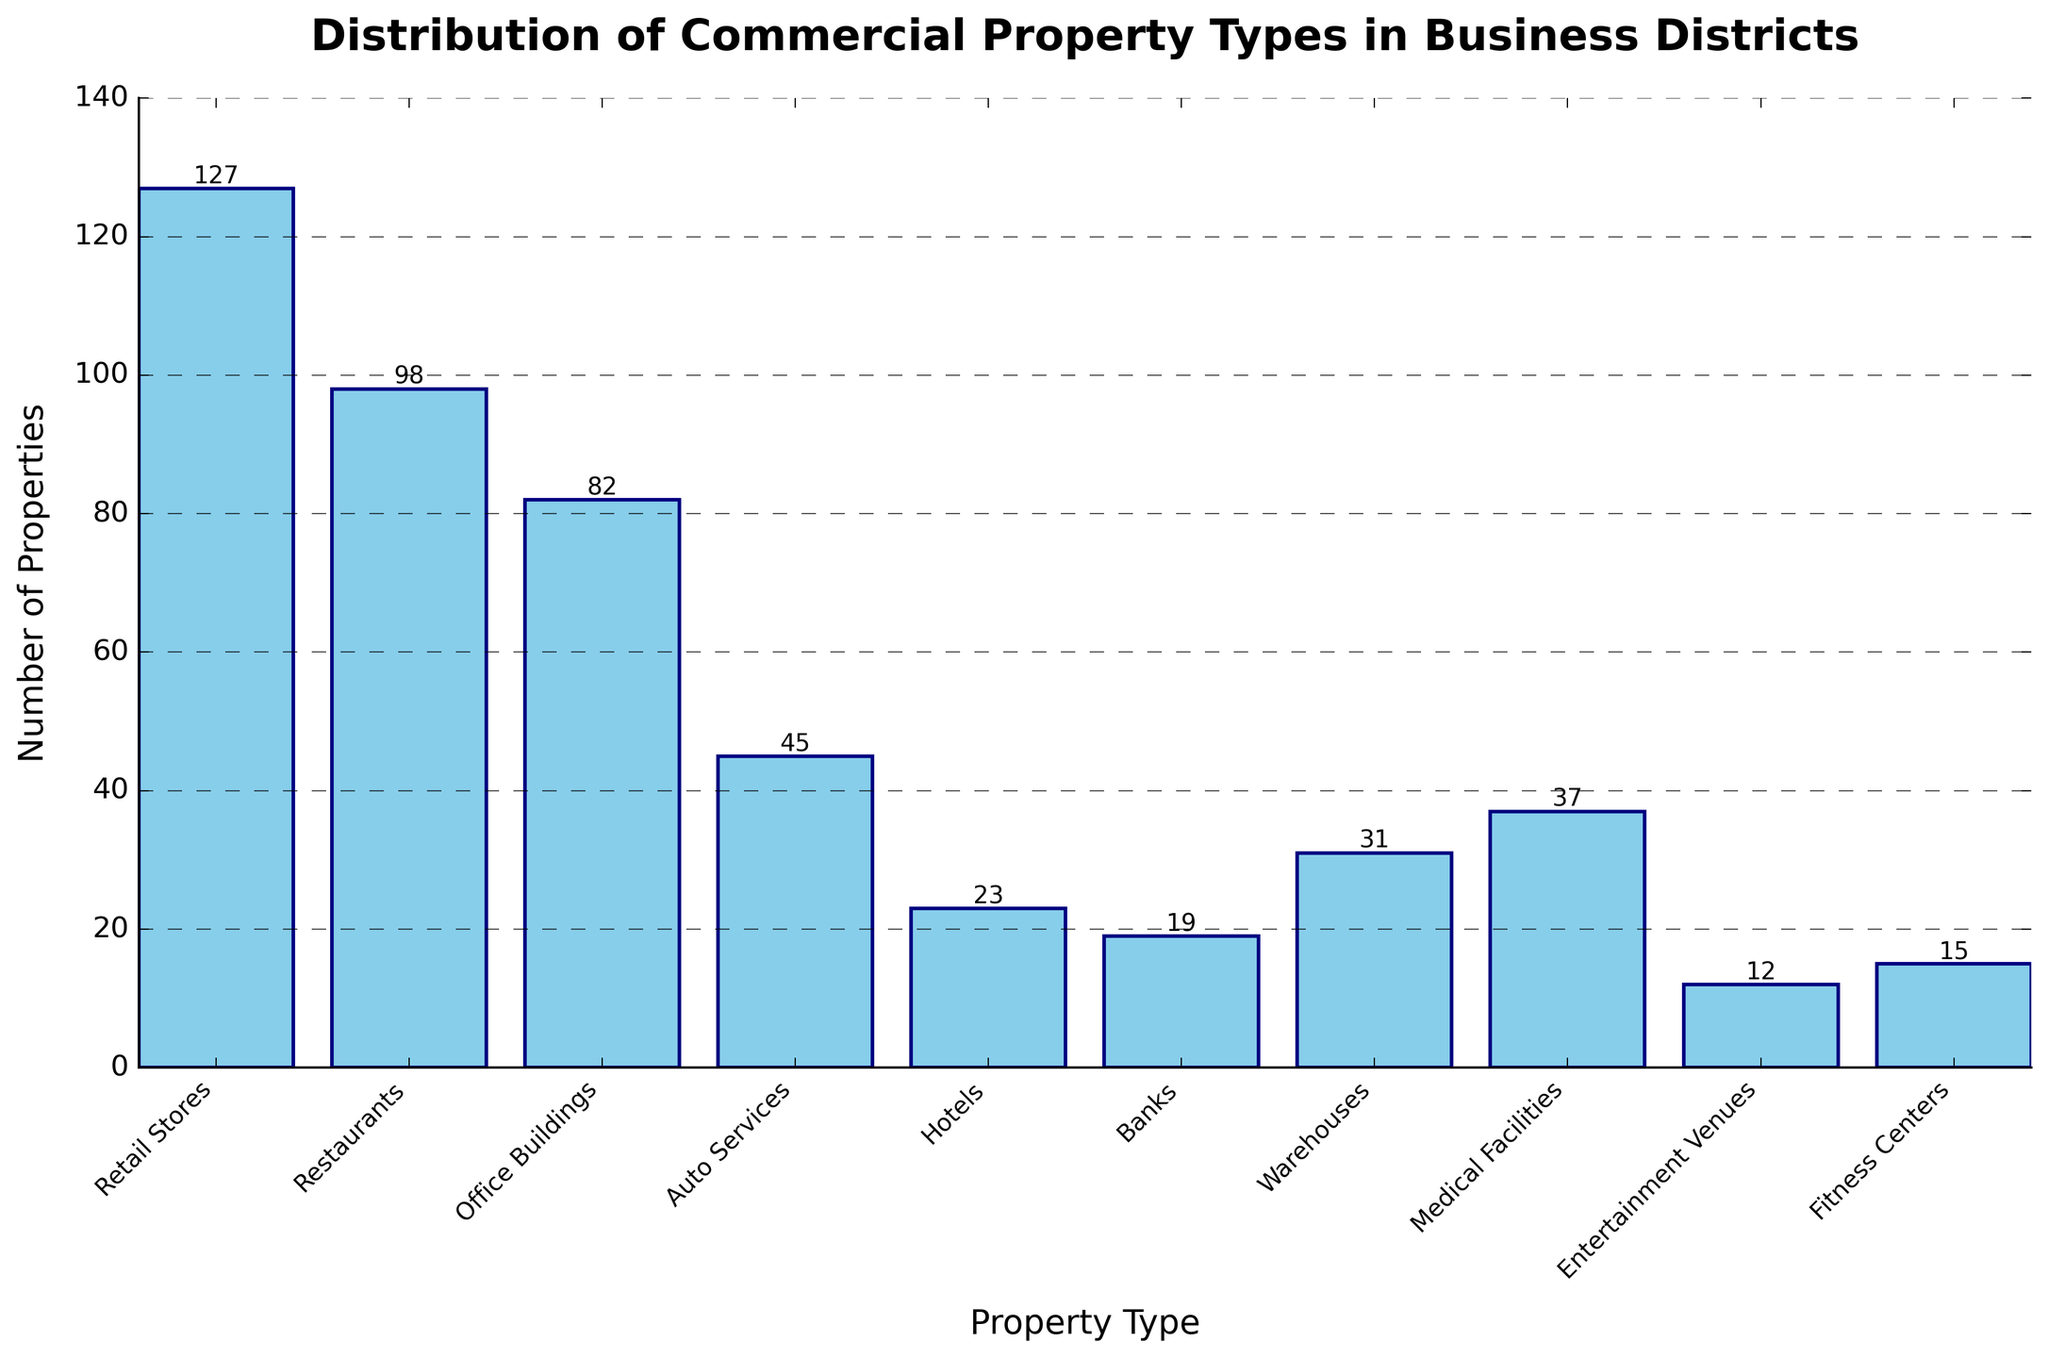Which property type has the highest number of properties? Observe the height of the bars. The tallest bar corresponds to Retail Stores.
Answer: Retail Stores Which property type has fewer properties: Auto Services or Hotels? Compare the heights of the bars for Auto Services and Hotels. Auto Services has more properties than Hotels.
Answer: Hotels What is the combined total number of Restaurants, Banks, and Fitness Centers? Add the number of properties for Restaurants (98), Banks (19), and Fitness Centers (15). 98 + 19 + 15 = 132.
Answer: 132 How does the number of Entertainment Venues compare to that of Medical Facilities? Compare the heights of the bars. Medical Facilities have more properties than Entertainment Venues.
Answer: Medical Facilities have more What is the total number of properties excluding Retail Stores and Restaurants? Subtract the number of Retail Stores and Restaurants from the total number of properties. Total properties: 127 + 98 + 82 + 45 + 23 + 19 + 31 + 37 + 12 + 15 = 489. Exclude Retail Stores and Restaurants: 489 - 127 - 98 = 264.
Answer: 264 Which two property types have the closest number of properties? Compare the heights of the bars to find the ones with similar heights. Office Buildings (82) and Medical Facilities (37) look closer than others but upon closer inspection, Medical Facilities and Warehouses have a smaller difference of 6 (37 - 31 = 6).
Answer: Medical Facilities and Warehouses Is the number of Office Buildings greater than the sum of Hotels and Banks? Calculate the sum of properties for Hotels and Banks: 23 + 19 = 42. Compare 42 with the number of Office Buildings, which is 82.
Answer: Yes Which property types have fewer than 20 properties? Identify the bars with heights less than 20. Bars for Banks (19), Entertainment Venues (12), and Fitness Centers (15).
Answer: Banks, Entertainment Venues, Fitness Centers Which property type falls exactly in the middle (5th position) when sorted by the number of properties? Sort the property types by the number of properties and find the middle one. Sorted order: Entertainment Venues (12), Fitness Centers (15), Banks (19), Hotels (23), Warehouses (31), Medical Facilities (37), Auto Services (45), Office Buildings (82), Restaurants (98), Retail Stores (127). The 5th one is Warehouses.
Answer: Warehouses 